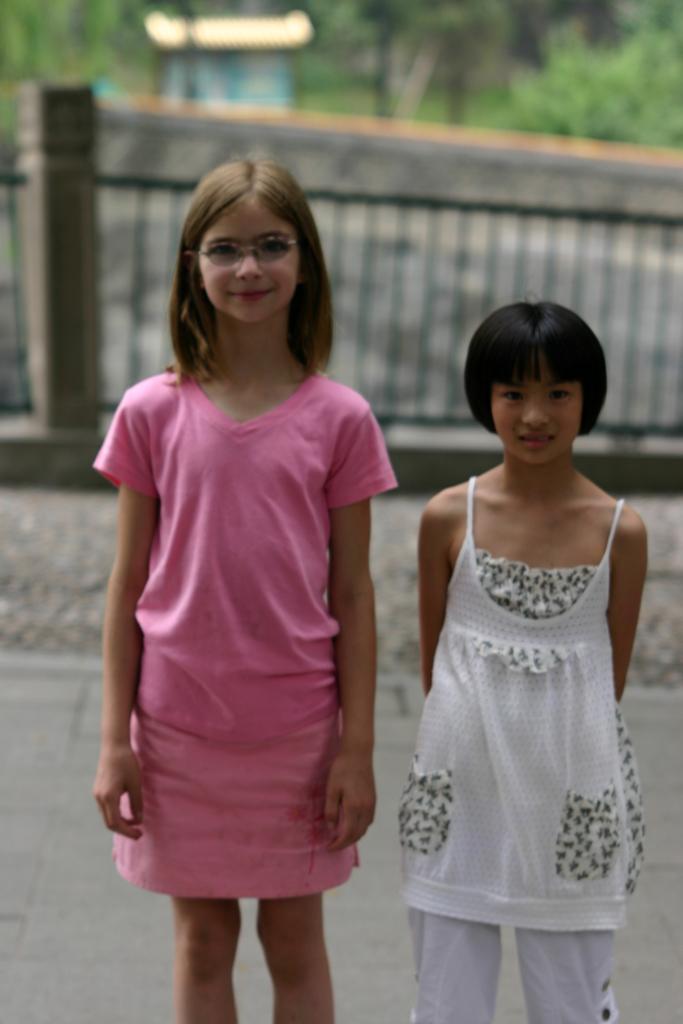Please provide a concise description of this image. In this image in the center there are girls standing and smiling and the background is blurry. 